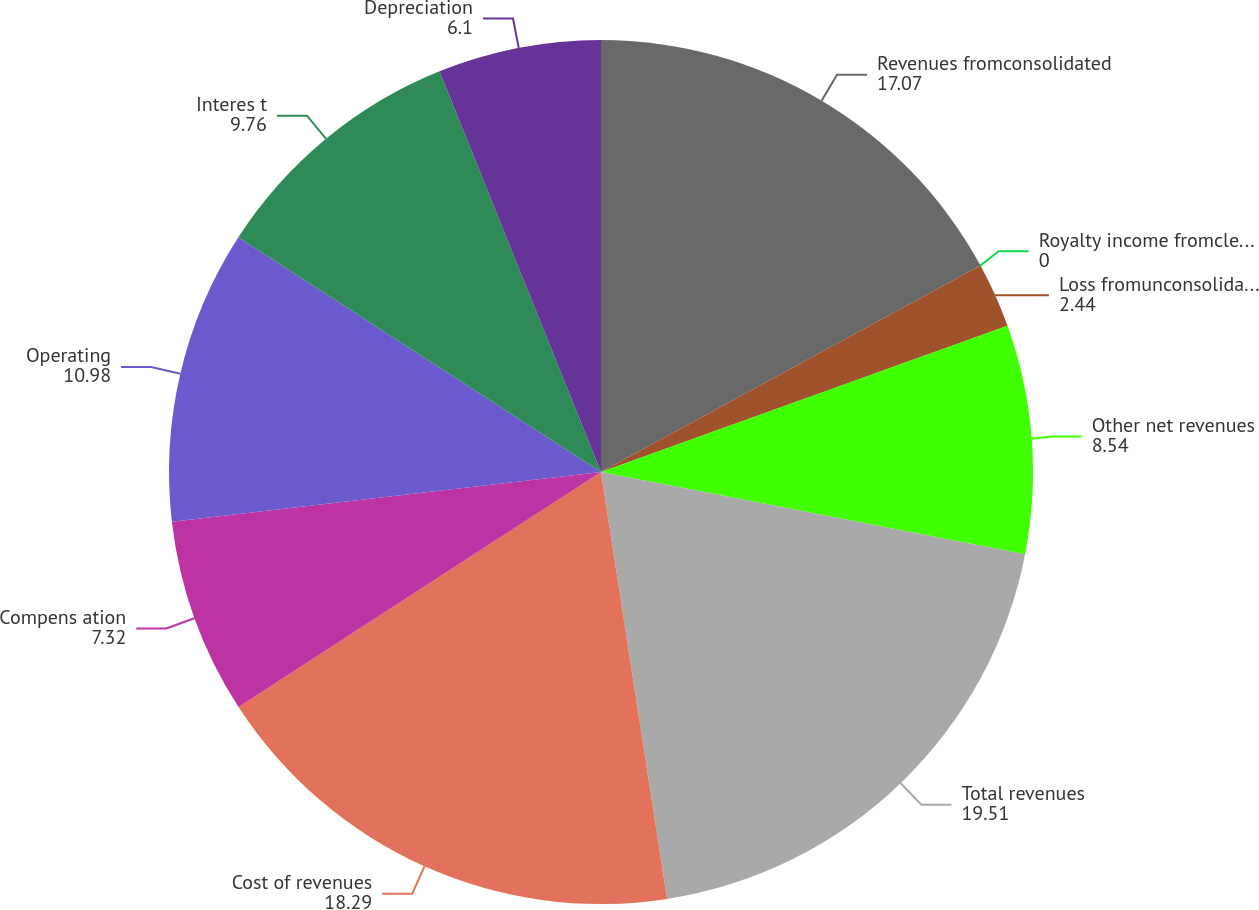Convert chart to OTSL. <chart><loc_0><loc_0><loc_500><loc_500><pie_chart><fcel>Revenues fromconsolidated<fcel>Royalty income fromclean coal<fcel>Loss fromunconsolidated clean<fcel>Other net revenues<fcel>Total revenues<fcel>Cost of revenues<fcel>Compens ation<fcel>Operating<fcel>Interes t<fcel>Depreciation<nl><fcel>17.07%<fcel>0.0%<fcel>2.44%<fcel>8.54%<fcel>19.51%<fcel>18.29%<fcel>7.32%<fcel>10.98%<fcel>9.76%<fcel>6.1%<nl></chart> 